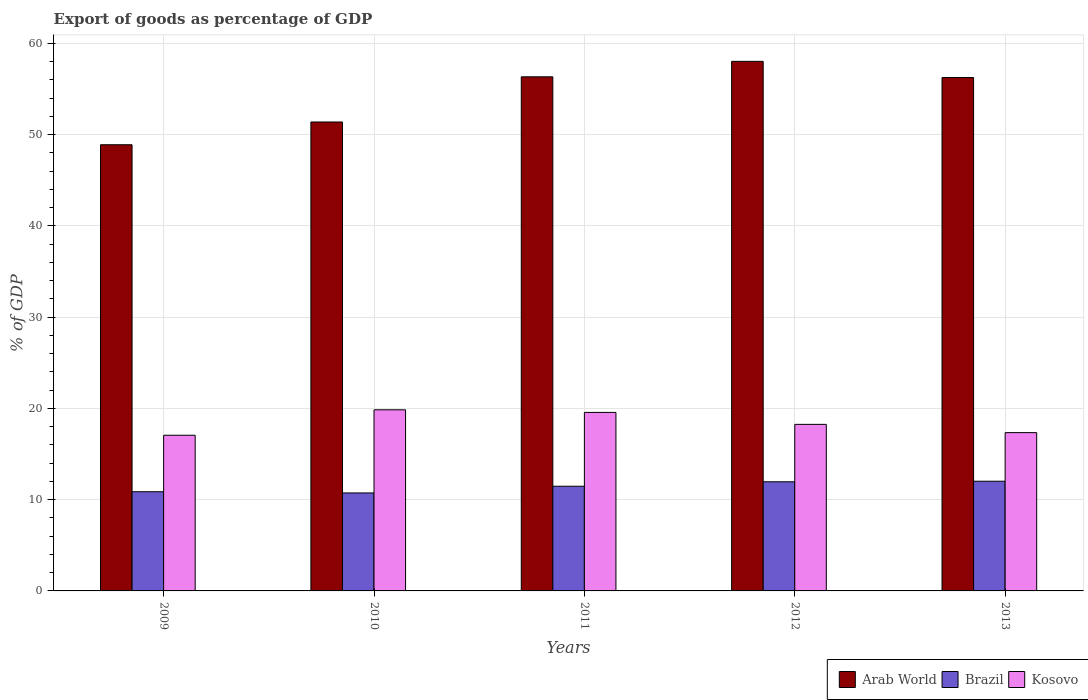How many different coloured bars are there?
Offer a very short reply. 3. Are the number of bars on each tick of the X-axis equal?
Keep it short and to the point. Yes. How many bars are there on the 3rd tick from the left?
Provide a succinct answer. 3. What is the label of the 4th group of bars from the left?
Make the answer very short. 2012. What is the export of goods as percentage of GDP in Kosovo in 2010?
Give a very brief answer. 19.85. Across all years, what is the maximum export of goods as percentage of GDP in Kosovo?
Provide a succinct answer. 19.85. Across all years, what is the minimum export of goods as percentage of GDP in Kosovo?
Make the answer very short. 17.06. What is the total export of goods as percentage of GDP in Brazil in the graph?
Offer a very short reply. 57.05. What is the difference between the export of goods as percentage of GDP in Kosovo in 2012 and that in 2013?
Your response must be concise. 0.91. What is the difference between the export of goods as percentage of GDP in Brazil in 2010 and the export of goods as percentage of GDP in Kosovo in 2013?
Your answer should be very brief. -6.61. What is the average export of goods as percentage of GDP in Kosovo per year?
Your answer should be very brief. 18.41. In the year 2010, what is the difference between the export of goods as percentage of GDP in Brazil and export of goods as percentage of GDP in Arab World?
Ensure brevity in your answer.  -40.65. In how many years, is the export of goods as percentage of GDP in Arab World greater than 20 %?
Offer a very short reply. 5. What is the ratio of the export of goods as percentage of GDP in Brazil in 2009 to that in 2013?
Make the answer very short. 0.9. Is the export of goods as percentage of GDP in Arab World in 2009 less than that in 2013?
Give a very brief answer. Yes. What is the difference between the highest and the second highest export of goods as percentage of GDP in Kosovo?
Provide a succinct answer. 0.29. What is the difference between the highest and the lowest export of goods as percentage of GDP in Arab World?
Your response must be concise. 9.14. Is the sum of the export of goods as percentage of GDP in Arab World in 2009 and 2012 greater than the maximum export of goods as percentage of GDP in Brazil across all years?
Your response must be concise. Yes. What does the 3rd bar from the left in 2010 represents?
Offer a very short reply. Kosovo. What does the 3rd bar from the right in 2012 represents?
Provide a short and direct response. Arab World. Are all the bars in the graph horizontal?
Your answer should be compact. No. How many years are there in the graph?
Give a very brief answer. 5. What is the difference between two consecutive major ticks on the Y-axis?
Give a very brief answer. 10. Does the graph contain any zero values?
Your response must be concise. No. Where does the legend appear in the graph?
Your answer should be very brief. Bottom right. How are the legend labels stacked?
Offer a terse response. Horizontal. What is the title of the graph?
Ensure brevity in your answer.  Export of goods as percentage of GDP. What is the label or title of the X-axis?
Keep it short and to the point. Years. What is the label or title of the Y-axis?
Your answer should be compact. % of GDP. What is the % of GDP of Arab World in 2009?
Your answer should be compact. 48.89. What is the % of GDP in Brazil in 2009?
Offer a terse response. 10.87. What is the % of GDP in Kosovo in 2009?
Your answer should be very brief. 17.06. What is the % of GDP of Arab World in 2010?
Offer a very short reply. 51.38. What is the % of GDP of Brazil in 2010?
Keep it short and to the point. 10.74. What is the % of GDP in Kosovo in 2010?
Make the answer very short. 19.85. What is the % of GDP of Arab World in 2011?
Provide a succinct answer. 56.33. What is the % of GDP in Brazil in 2011?
Keep it short and to the point. 11.47. What is the % of GDP of Kosovo in 2011?
Your response must be concise. 19.56. What is the % of GDP in Arab World in 2012?
Provide a short and direct response. 58.03. What is the % of GDP of Brazil in 2012?
Make the answer very short. 11.96. What is the % of GDP in Kosovo in 2012?
Keep it short and to the point. 18.25. What is the % of GDP of Arab World in 2013?
Offer a terse response. 56.25. What is the % of GDP of Brazil in 2013?
Provide a short and direct response. 12.02. What is the % of GDP of Kosovo in 2013?
Your response must be concise. 17.34. Across all years, what is the maximum % of GDP of Arab World?
Provide a succinct answer. 58.03. Across all years, what is the maximum % of GDP in Brazil?
Keep it short and to the point. 12.02. Across all years, what is the maximum % of GDP of Kosovo?
Your response must be concise. 19.85. Across all years, what is the minimum % of GDP in Arab World?
Offer a terse response. 48.89. Across all years, what is the minimum % of GDP in Brazil?
Your response must be concise. 10.74. Across all years, what is the minimum % of GDP of Kosovo?
Offer a terse response. 17.06. What is the total % of GDP in Arab World in the graph?
Offer a very short reply. 270.88. What is the total % of GDP in Brazil in the graph?
Provide a short and direct response. 57.05. What is the total % of GDP in Kosovo in the graph?
Make the answer very short. 92.06. What is the difference between the % of GDP in Arab World in 2009 and that in 2010?
Your answer should be very brief. -2.49. What is the difference between the % of GDP in Brazil in 2009 and that in 2010?
Your answer should be very brief. 0.13. What is the difference between the % of GDP of Kosovo in 2009 and that in 2010?
Provide a short and direct response. -2.79. What is the difference between the % of GDP of Arab World in 2009 and that in 2011?
Your answer should be very brief. -7.44. What is the difference between the % of GDP of Brazil in 2009 and that in 2011?
Give a very brief answer. -0.6. What is the difference between the % of GDP of Kosovo in 2009 and that in 2011?
Provide a short and direct response. -2.5. What is the difference between the % of GDP in Arab World in 2009 and that in 2012?
Provide a succinct answer. -9.14. What is the difference between the % of GDP in Brazil in 2009 and that in 2012?
Give a very brief answer. -1.09. What is the difference between the % of GDP in Kosovo in 2009 and that in 2012?
Keep it short and to the point. -1.19. What is the difference between the % of GDP in Arab World in 2009 and that in 2013?
Make the answer very short. -7.37. What is the difference between the % of GDP of Brazil in 2009 and that in 2013?
Make the answer very short. -1.15. What is the difference between the % of GDP of Kosovo in 2009 and that in 2013?
Provide a succinct answer. -0.29. What is the difference between the % of GDP in Arab World in 2010 and that in 2011?
Your answer should be very brief. -4.95. What is the difference between the % of GDP of Brazil in 2010 and that in 2011?
Provide a succinct answer. -0.73. What is the difference between the % of GDP in Kosovo in 2010 and that in 2011?
Make the answer very short. 0.29. What is the difference between the % of GDP of Arab World in 2010 and that in 2012?
Offer a very short reply. -6.64. What is the difference between the % of GDP of Brazil in 2010 and that in 2012?
Offer a terse response. -1.22. What is the difference between the % of GDP of Kosovo in 2010 and that in 2012?
Offer a very short reply. 1.59. What is the difference between the % of GDP in Arab World in 2010 and that in 2013?
Ensure brevity in your answer.  -4.87. What is the difference between the % of GDP in Brazil in 2010 and that in 2013?
Your answer should be compact. -1.28. What is the difference between the % of GDP in Kosovo in 2010 and that in 2013?
Your response must be concise. 2.5. What is the difference between the % of GDP in Arab World in 2011 and that in 2012?
Make the answer very short. -1.69. What is the difference between the % of GDP of Brazil in 2011 and that in 2012?
Make the answer very short. -0.49. What is the difference between the % of GDP in Kosovo in 2011 and that in 2012?
Keep it short and to the point. 1.31. What is the difference between the % of GDP of Arab World in 2011 and that in 2013?
Keep it short and to the point. 0.08. What is the difference between the % of GDP in Brazil in 2011 and that in 2013?
Keep it short and to the point. -0.55. What is the difference between the % of GDP in Kosovo in 2011 and that in 2013?
Provide a short and direct response. 2.21. What is the difference between the % of GDP in Arab World in 2012 and that in 2013?
Offer a very short reply. 1.77. What is the difference between the % of GDP of Brazil in 2012 and that in 2013?
Your answer should be compact. -0.06. What is the difference between the % of GDP in Kosovo in 2012 and that in 2013?
Provide a short and direct response. 0.91. What is the difference between the % of GDP in Arab World in 2009 and the % of GDP in Brazil in 2010?
Keep it short and to the point. 38.15. What is the difference between the % of GDP in Arab World in 2009 and the % of GDP in Kosovo in 2010?
Your answer should be very brief. 29.04. What is the difference between the % of GDP of Brazil in 2009 and the % of GDP of Kosovo in 2010?
Your answer should be compact. -8.98. What is the difference between the % of GDP in Arab World in 2009 and the % of GDP in Brazil in 2011?
Offer a terse response. 37.42. What is the difference between the % of GDP in Arab World in 2009 and the % of GDP in Kosovo in 2011?
Provide a short and direct response. 29.33. What is the difference between the % of GDP of Brazil in 2009 and the % of GDP of Kosovo in 2011?
Provide a succinct answer. -8.69. What is the difference between the % of GDP in Arab World in 2009 and the % of GDP in Brazil in 2012?
Offer a very short reply. 36.93. What is the difference between the % of GDP of Arab World in 2009 and the % of GDP of Kosovo in 2012?
Your answer should be very brief. 30.64. What is the difference between the % of GDP of Brazil in 2009 and the % of GDP of Kosovo in 2012?
Provide a succinct answer. -7.38. What is the difference between the % of GDP in Arab World in 2009 and the % of GDP in Brazil in 2013?
Keep it short and to the point. 36.87. What is the difference between the % of GDP of Arab World in 2009 and the % of GDP of Kosovo in 2013?
Provide a succinct answer. 31.54. What is the difference between the % of GDP of Brazil in 2009 and the % of GDP of Kosovo in 2013?
Make the answer very short. -6.48. What is the difference between the % of GDP of Arab World in 2010 and the % of GDP of Brazil in 2011?
Provide a succinct answer. 39.91. What is the difference between the % of GDP in Arab World in 2010 and the % of GDP in Kosovo in 2011?
Offer a terse response. 31.82. What is the difference between the % of GDP of Brazil in 2010 and the % of GDP of Kosovo in 2011?
Provide a succinct answer. -8.82. What is the difference between the % of GDP in Arab World in 2010 and the % of GDP in Brazil in 2012?
Provide a succinct answer. 39.42. What is the difference between the % of GDP in Arab World in 2010 and the % of GDP in Kosovo in 2012?
Provide a short and direct response. 33.13. What is the difference between the % of GDP in Brazil in 2010 and the % of GDP in Kosovo in 2012?
Your response must be concise. -7.51. What is the difference between the % of GDP in Arab World in 2010 and the % of GDP in Brazil in 2013?
Your answer should be compact. 39.36. What is the difference between the % of GDP in Arab World in 2010 and the % of GDP in Kosovo in 2013?
Give a very brief answer. 34.04. What is the difference between the % of GDP in Brazil in 2010 and the % of GDP in Kosovo in 2013?
Make the answer very short. -6.61. What is the difference between the % of GDP of Arab World in 2011 and the % of GDP of Brazil in 2012?
Provide a short and direct response. 44.37. What is the difference between the % of GDP of Arab World in 2011 and the % of GDP of Kosovo in 2012?
Provide a short and direct response. 38.08. What is the difference between the % of GDP in Brazil in 2011 and the % of GDP in Kosovo in 2012?
Offer a very short reply. -6.78. What is the difference between the % of GDP in Arab World in 2011 and the % of GDP in Brazil in 2013?
Provide a short and direct response. 44.31. What is the difference between the % of GDP in Arab World in 2011 and the % of GDP in Kosovo in 2013?
Provide a short and direct response. 38.99. What is the difference between the % of GDP of Brazil in 2011 and the % of GDP of Kosovo in 2013?
Offer a very short reply. -5.87. What is the difference between the % of GDP of Arab World in 2012 and the % of GDP of Brazil in 2013?
Make the answer very short. 46.01. What is the difference between the % of GDP in Arab World in 2012 and the % of GDP in Kosovo in 2013?
Provide a short and direct response. 40.68. What is the difference between the % of GDP in Brazil in 2012 and the % of GDP in Kosovo in 2013?
Give a very brief answer. -5.39. What is the average % of GDP in Arab World per year?
Make the answer very short. 54.18. What is the average % of GDP of Brazil per year?
Make the answer very short. 11.41. What is the average % of GDP in Kosovo per year?
Offer a very short reply. 18.41. In the year 2009, what is the difference between the % of GDP of Arab World and % of GDP of Brazil?
Your answer should be very brief. 38.02. In the year 2009, what is the difference between the % of GDP of Arab World and % of GDP of Kosovo?
Keep it short and to the point. 31.83. In the year 2009, what is the difference between the % of GDP in Brazil and % of GDP in Kosovo?
Give a very brief answer. -6.19. In the year 2010, what is the difference between the % of GDP of Arab World and % of GDP of Brazil?
Keep it short and to the point. 40.65. In the year 2010, what is the difference between the % of GDP in Arab World and % of GDP in Kosovo?
Give a very brief answer. 31.54. In the year 2010, what is the difference between the % of GDP of Brazil and % of GDP of Kosovo?
Ensure brevity in your answer.  -9.11. In the year 2011, what is the difference between the % of GDP in Arab World and % of GDP in Brazil?
Make the answer very short. 44.86. In the year 2011, what is the difference between the % of GDP in Arab World and % of GDP in Kosovo?
Make the answer very short. 36.77. In the year 2011, what is the difference between the % of GDP of Brazil and % of GDP of Kosovo?
Your response must be concise. -8.09. In the year 2012, what is the difference between the % of GDP of Arab World and % of GDP of Brazil?
Your response must be concise. 46.07. In the year 2012, what is the difference between the % of GDP of Arab World and % of GDP of Kosovo?
Provide a succinct answer. 39.77. In the year 2012, what is the difference between the % of GDP of Brazil and % of GDP of Kosovo?
Give a very brief answer. -6.29. In the year 2013, what is the difference between the % of GDP of Arab World and % of GDP of Brazil?
Your response must be concise. 44.23. In the year 2013, what is the difference between the % of GDP of Arab World and % of GDP of Kosovo?
Provide a short and direct response. 38.91. In the year 2013, what is the difference between the % of GDP in Brazil and % of GDP in Kosovo?
Your response must be concise. -5.33. What is the ratio of the % of GDP of Arab World in 2009 to that in 2010?
Keep it short and to the point. 0.95. What is the ratio of the % of GDP in Brazil in 2009 to that in 2010?
Your answer should be very brief. 1.01. What is the ratio of the % of GDP of Kosovo in 2009 to that in 2010?
Keep it short and to the point. 0.86. What is the ratio of the % of GDP in Arab World in 2009 to that in 2011?
Ensure brevity in your answer.  0.87. What is the ratio of the % of GDP in Brazil in 2009 to that in 2011?
Offer a terse response. 0.95. What is the ratio of the % of GDP in Kosovo in 2009 to that in 2011?
Your answer should be compact. 0.87. What is the ratio of the % of GDP of Arab World in 2009 to that in 2012?
Your answer should be very brief. 0.84. What is the ratio of the % of GDP in Brazil in 2009 to that in 2012?
Offer a terse response. 0.91. What is the ratio of the % of GDP in Kosovo in 2009 to that in 2012?
Provide a short and direct response. 0.93. What is the ratio of the % of GDP of Arab World in 2009 to that in 2013?
Give a very brief answer. 0.87. What is the ratio of the % of GDP in Brazil in 2009 to that in 2013?
Offer a very short reply. 0.9. What is the ratio of the % of GDP of Kosovo in 2009 to that in 2013?
Provide a short and direct response. 0.98. What is the ratio of the % of GDP of Arab World in 2010 to that in 2011?
Offer a terse response. 0.91. What is the ratio of the % of GDP of Brazil in 2010 to that in 2011?
Make the answer very short. 0.94. What is the ratio of the % of GDP of Kosovo in 2010 to that in 2011?
Ensure brevity in your answer.  1.01. What is the ratio of the % of GDP in Arab World in 2010 to that in 2012?
Offer a terse response. 0.89. What is the ratio of the % of GDP in Brazil in 2010 to that in 2012?
Offer a very short reply. 0.9. What is the ratio of the % of GDP in Kosovo in 2010 to that in 2012?
Ensure brevity in your answer.  1.09. What is the ratio of the % of GDP in Arab World in 2010 to that in 2013?
Offer a terse response. 0.91. What is the ratio of the % of GDP in Brazil in 2010 to that in 2013?
Give a very brief answer. 0.89. What is the ratio of the % of GDP of Kosovo in 2010 to that in 2013?
Your response must be concise. 1.14. What is the ratio of the % of GDP in Arab World in 2011 to that in 2012?
Make the answer very short. 0.97. What is the ratio of the % of GDP of Brazil in 2011 to that in 2012?
Give a very brief answer. 0.96. What is the ratio of the % of GDP of Kosovo in 2011 to that in 2012?
Ensure brevity in your answer.  1.07. What is the ratio of the % of GDP in Brazil in 2011 to that in 2013?
Provide a succinct answer. 0.95. What is the ratio of the % of GDP in Kosovo in 2011 to that in 2013?
Keep it short and to the point. 1.13. What is the ratio of the % of GDP in Arab World in 2012 to that in 2013?
Keep it short and to the point. 1.03. What is the ratio of the % of GDP in Brazil in 2012 to that in 2013?
Give a very brief answer. 0.99. What is the ratio of the % of GDP in Kosovo in 2012 to that in 2013?
Provide a succinct answer. 1.05. What is the difference between the highest and the second highest % of GDP in Arab World?
Offer a terse response. 1.69. What is the difference between the highest and the second highest % of GDP in Brazil?
Your answer should be very brief. 0.06. What is the difference between the highest and the second highest % of GDP of Kosovo?
Offer a very short reply. 0.29. What is the difference between the highest and the lowest % of GDP of Arab World?
Give a very brief answer. 9.14. What is the difference between the highest and the lowest % of GDP of Brazil?
Ensure brevity in your answer.  1.28. What is the difference between the highest and the lowest % of GDP in Kosovo?
Offer a very short reply. 2.79. 